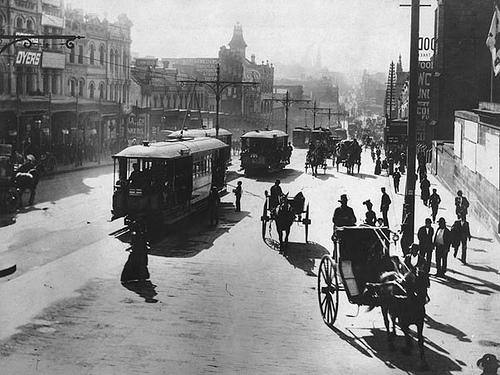Is this a city or country scene?
Concise answer only. City. What is pulling the carriages?
Answer briefly. Horses. Could these cars be powered with electricity?
Write a very short answer. Yes. 